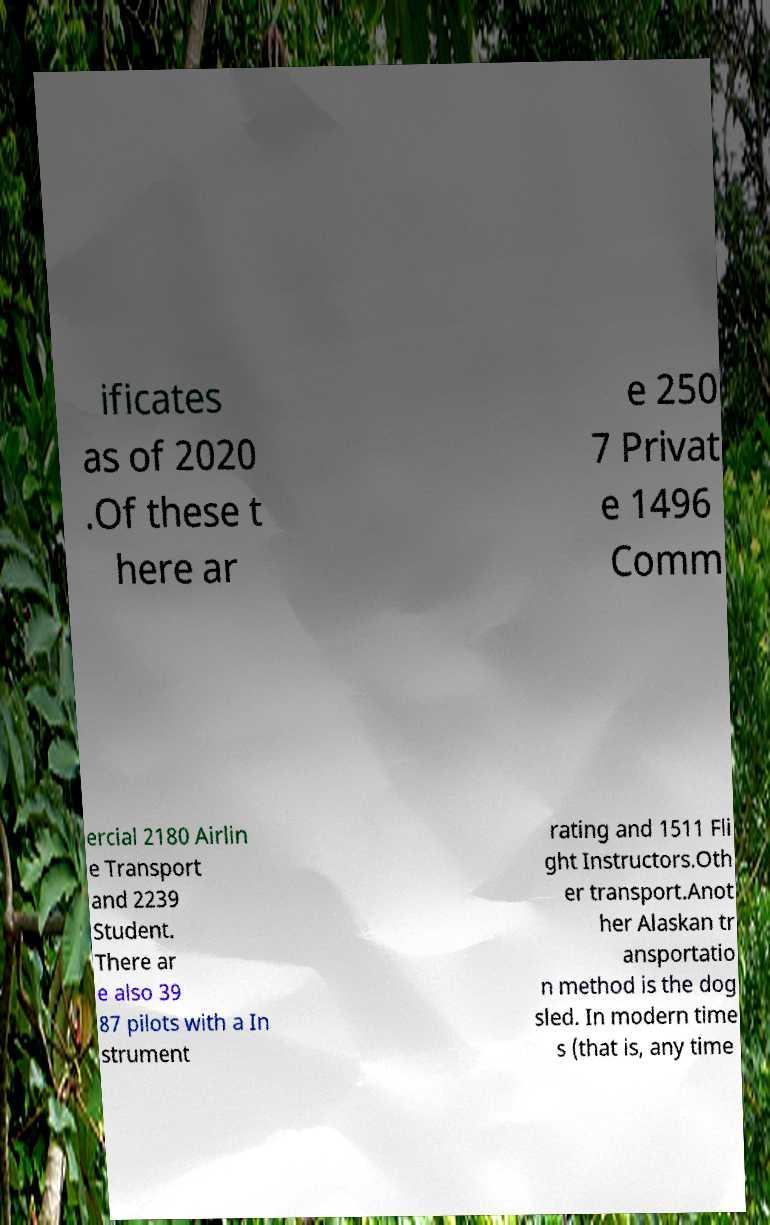Please read and relay the text visible in this image. What does it say? ificates as of 2020 .Of these t here ar e 250 7 Privat e 1496 Comm ercial 2180 Airlin e Transport and 2239 Student. There ar e also 39 87 pilots with a In strument rating and 1511 Fli ght Instructors.Oth er transport.Anot her Alaskan tr ansportatio n method is the dog sled. In modern time s (that is, any time 